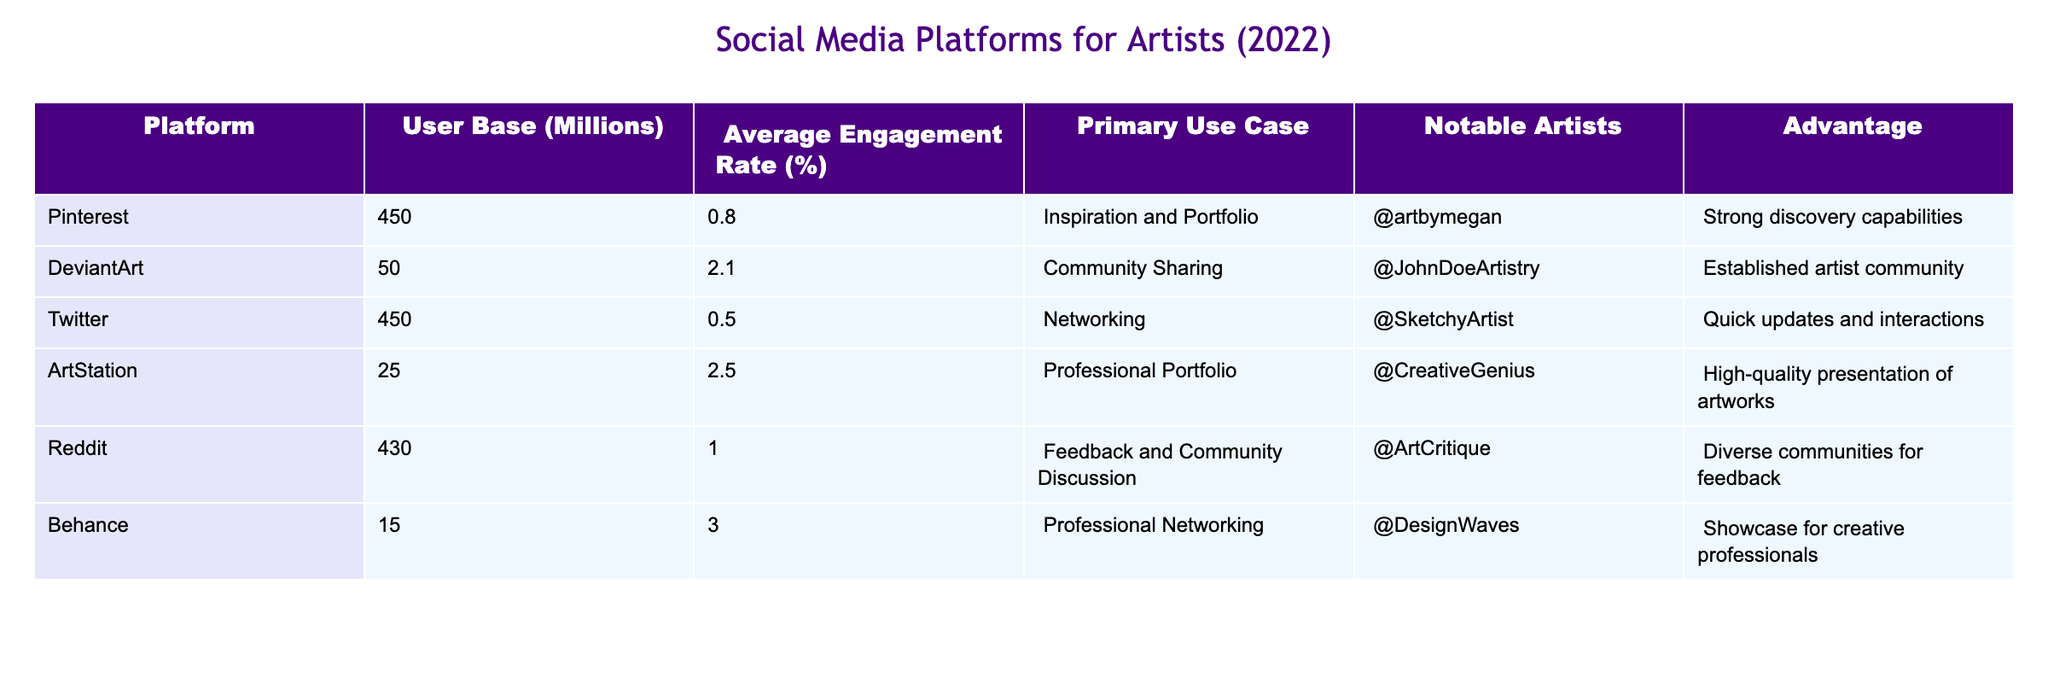What is the user base of Pinterest? According to the table, Pinterest has a user base of 450 million users.
Answer: 450 million Which platform has the highest average engagement rate? By comparing the average engagement rates listed, Behance has the highest rate at 3.00%.
Answer: Behance What is the primary use case for Reddit? The table indicates that Reddit's primary use case is for feedback and community discussion.
Answer: Feedback and community discussion Is Twitter known for its community sharing feature? The table shows that Twitter's primary use case is networking, not community sharing. Therefore, the answer is no.
Answer: No What is the combined user base of ArtStation and Behance? Adding the user bases of ArtStation (25 million) and Behance (15 million) gives 25 + 15 = 40 million users.
Answer: 40 million Which platforms have user bases greater than 400 million? Comparing the user bases, both Pinterest (450 million) and Twitter (450 million) exceed 400 million users.
Answer: Pinterest and Twitter Is there an artist noted for using DeviantArt? Yes, the table lists @JohnDoeArtistry as a notable artist on DeviantArt.
Answer: Yes What is the average user base of the platforms listed in the table? To find the average, sum the user bases: 450 + 50 + 450 + 25 + 430 + 15 = 1420 million. There are 6 platforms, so the average is 1420/6 = 236.67 million.
Answer: 236.67 million Which platform is primarily used for inspiration and portfolio sharing? According to the table, Pinterest is primarily used for inspiration and portfolio sharing.
Answer: Pinterest What is the notable advantage of using ArtStation? The table shows that ArtStation's notable advantage is its high-quality presentation of artworks.
Answer: High-quality presentation of artworks Are there more platforms focused on professional use cases than community use cases? The table identifies 3 platforms (ArtStation, Behance, and DeviantArt) as primarily professional or community-oriented, with 3 for each. Therefore, the answer is no.
Answer: No 